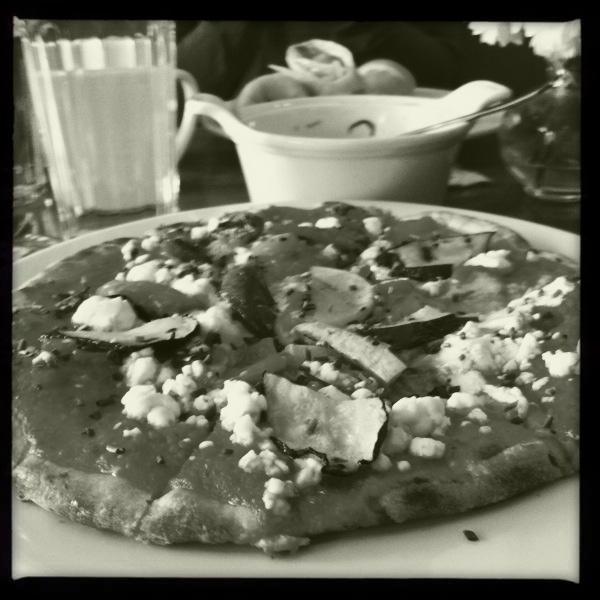Has anyone begun to eat the pizza?
Write a very short answer. No. Have people started to eat the pizza?
Concise answer only. No. What food is on the plate?
Keep it brief. Pizza. Is that a cheese pizza?
Write a very short answer. No. How many toppings are on this pizza?
Write a very short answer. 3. 